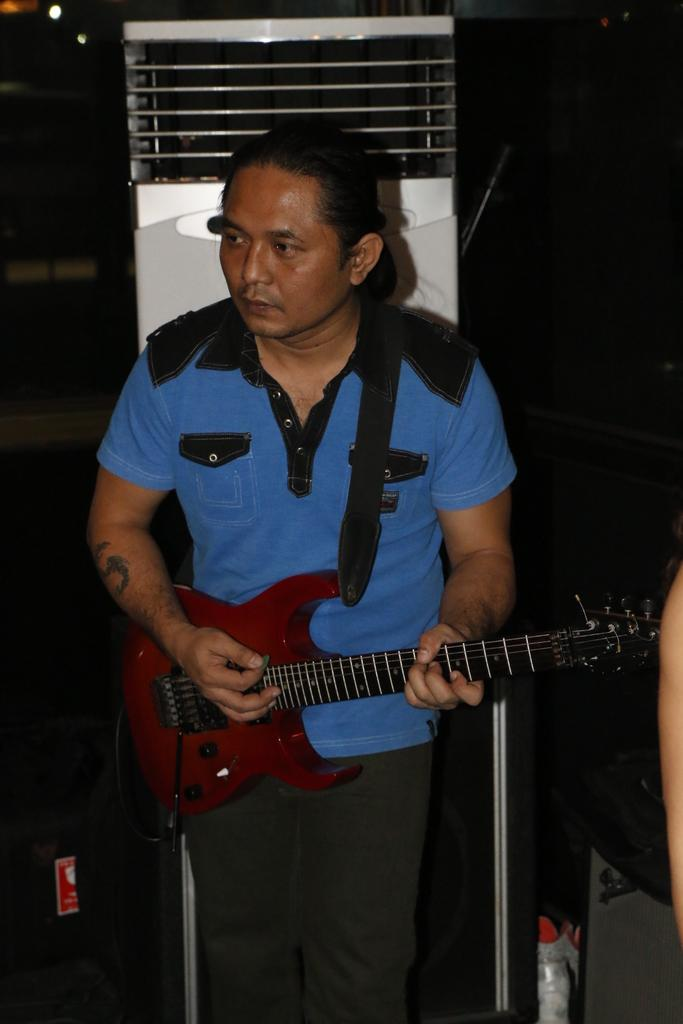Who is the person in the image? There is a man in the image. What is the man wearing? The man is wearing a blue t-shirt. What is the man holding in the image? The man is holding a guitar. What is the man doing with the guitar? The man is playing the guitar. What can be seen behind the man in the image? There is an air conditioner behind the man. How does the earthquake affect the man's guitar playing in the image? There is no earthquake present in the image, so its effect on the man's guitar playing cannot be determined. 